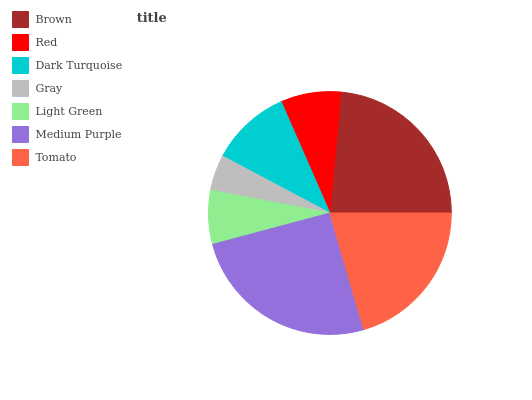Is Gray the minimum?
Answer yes or no. Yes. Is Medium Purple the maximum?
Answer yes or no. Yes. Is Red the minimum?
Answer yes or no. No. Is Red the maximum?
Answer yes or no. No. Is Brown greater than Red?
Answer yes or no. Yes. Is Red less than Brown?
Answer yes or no. Yes. Is Red greater than Brown?
Answer yes or no. No. Is Brown less than Red?
Answer yes or no. No. Is Dark Turquoise the high median?
Answer yes or no. Yes. Is Dark Turquoise the low median?
Answer yes or no. Yes. Is Tomato the high median?
Answer yes or no. No. Is Gray the low median?
Answer yes or no. No. 